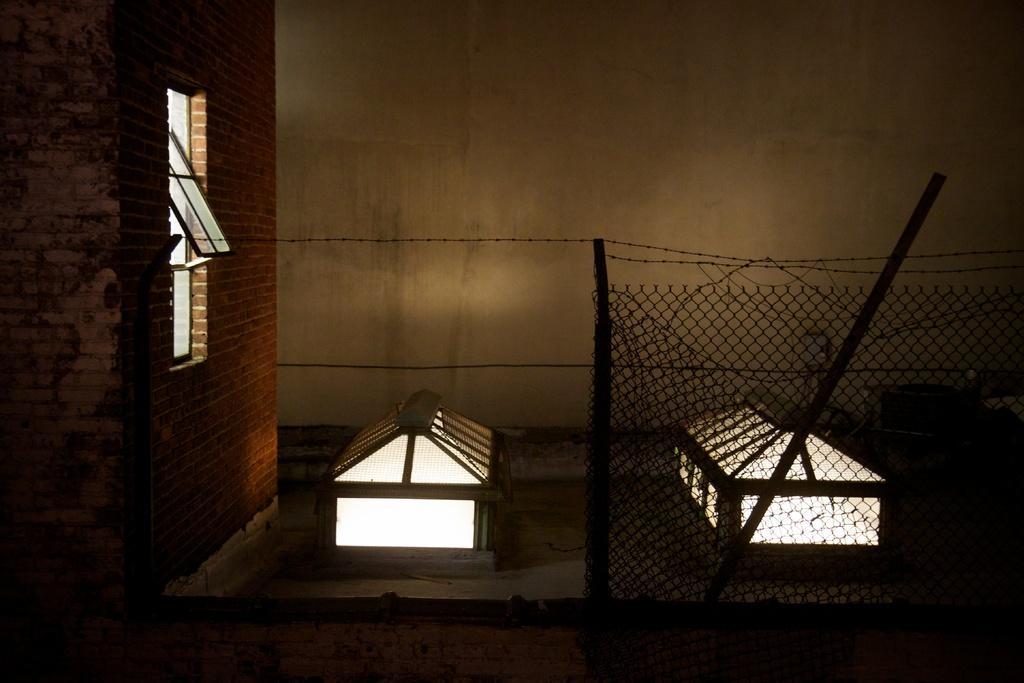In one or two sentences, can you explain what this image depicts? In this image, there is a window which is attached to the wall. There is fencing in front of the wall. 